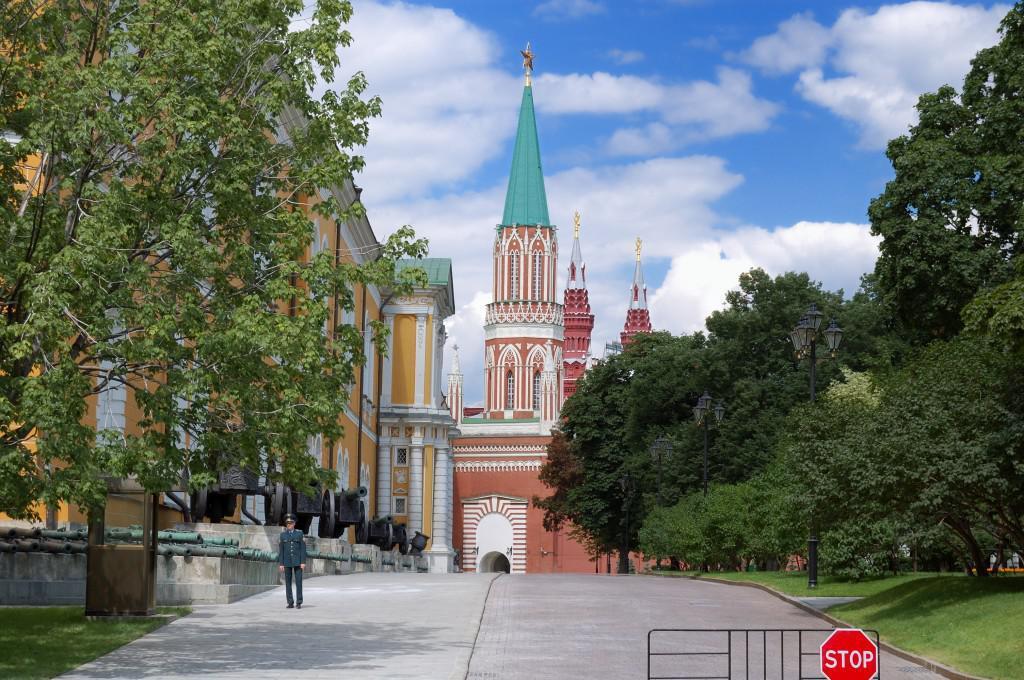Describe this image in one or two sentences. In this image I can see a person standing wearing blue color dress. Background I can see trees in green color, buildings in orange, brown and green color and sky is in white and blue color. 